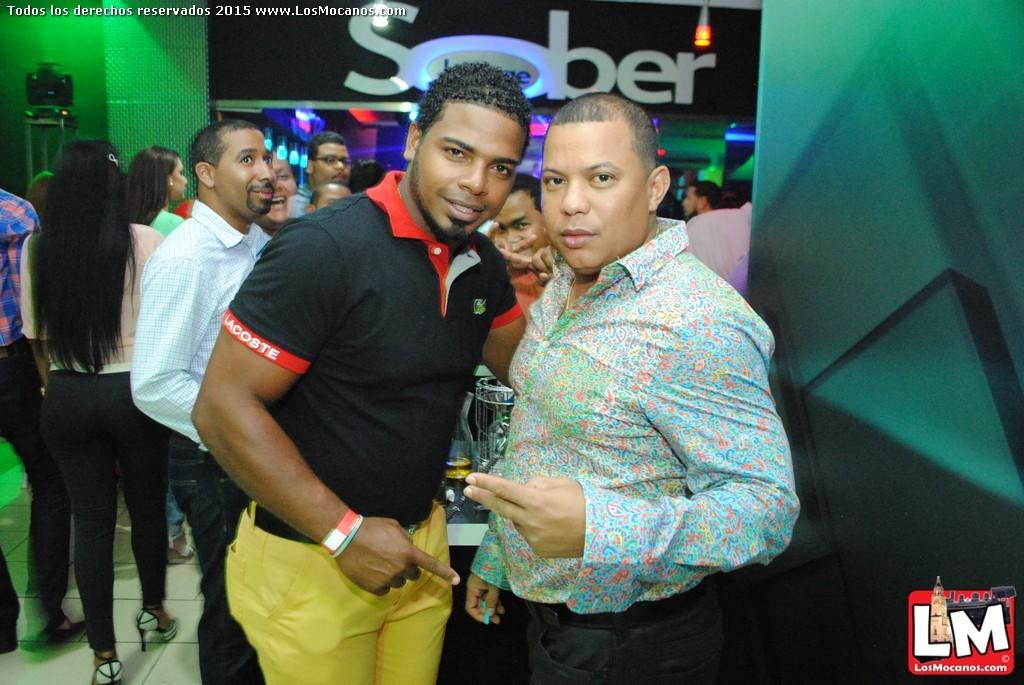Where was the image taken? The image was taken in a room. Who can be seen in the foreground of the image? There are two men standing in the foreground of the image. What can be seen in the background of the image? There are people visible in the background of the image, as well as a table. What is on the table in the background? There are glasses on the table. What additional details can be observed at the top of the image? There are name plates and lights visible at the top of the image. What type of toothbrush is being used by the owner of the glasses in the image? There is no toothbrush visible in the image, and no information about the ownership of the glasses is provided. 